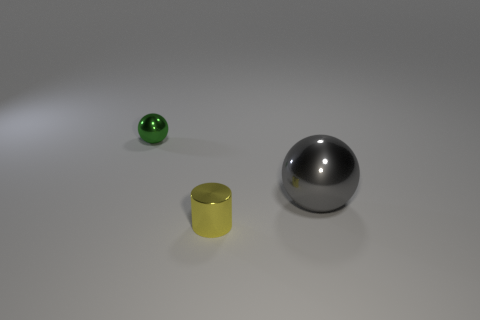Add 3 tiny blue cylinders. How many objects exist? 6 Subtract all balls. How many objects are left? 1 Add 1 brown metallic things. How many brown metallic things exist? 1 Subtract 0 brown balls. How many objects are left? 3 Subtract all large gray metallic spheres. Subtract all tiny brown rubber objects. How many objects are left? 2 Add 1 yellow metal cylinders. How many yellow metal cylinders are left? 2 